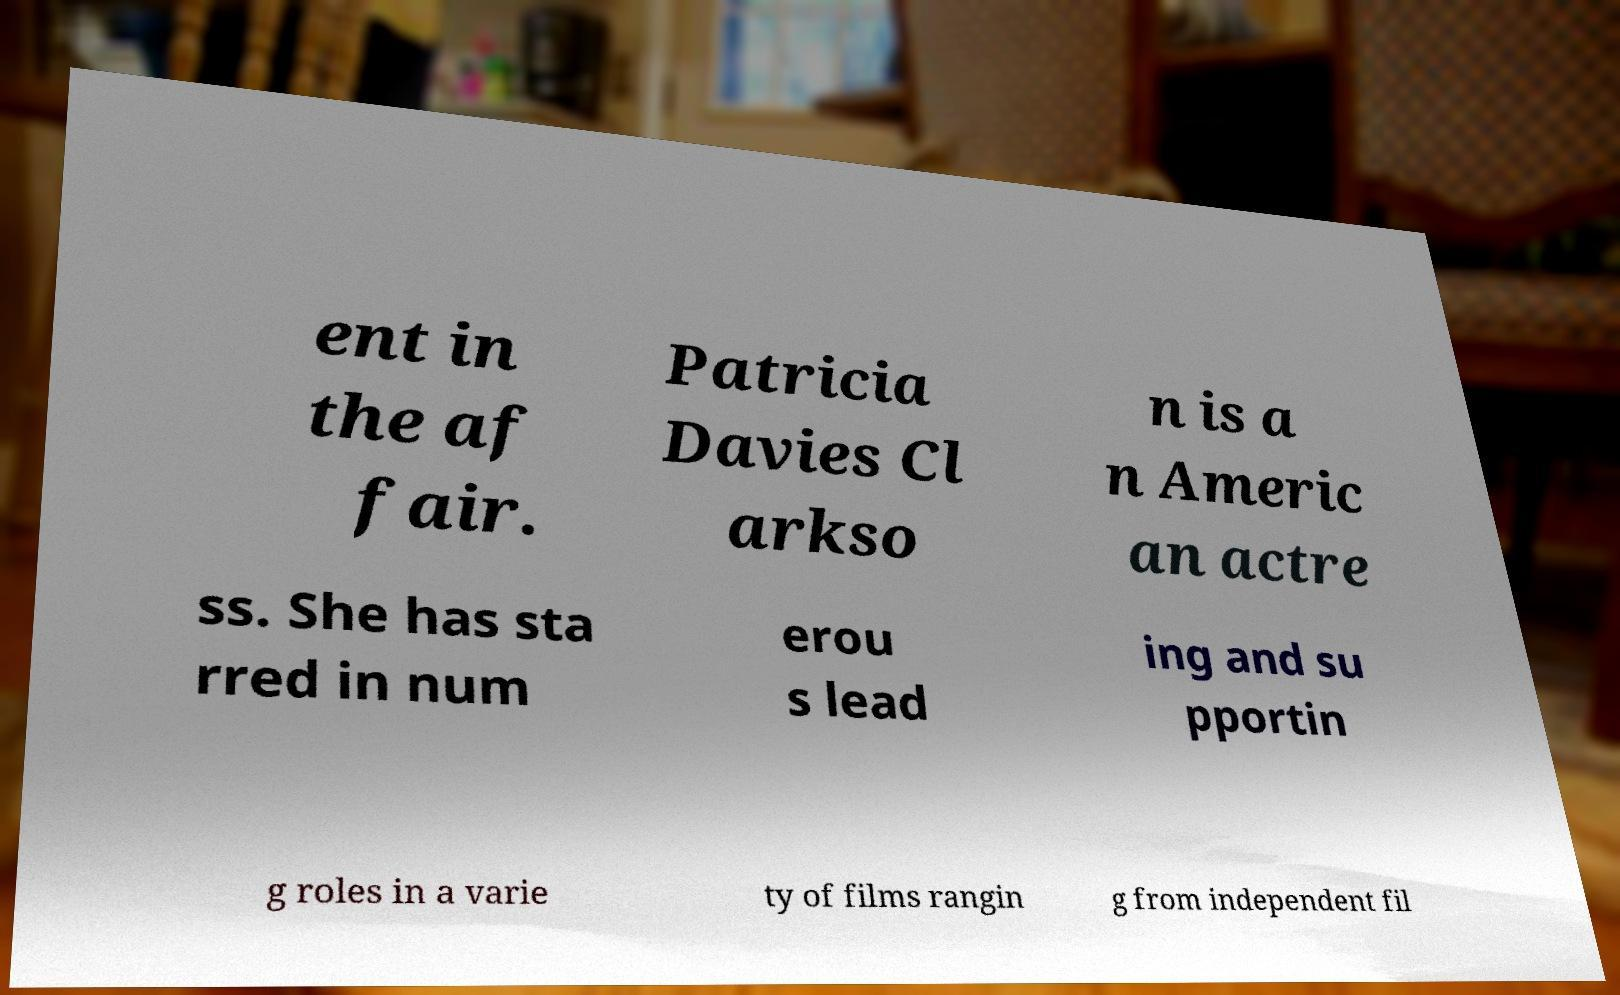Can you accurately transcribe the text from the provided image for me? ent in the af fair. Patricia Davies Cl arkso n is a n Americ an actre ss. She has sta rred in num erou s lead ing and su pportin g roles in a varie ty of films rangin g from independent fil 